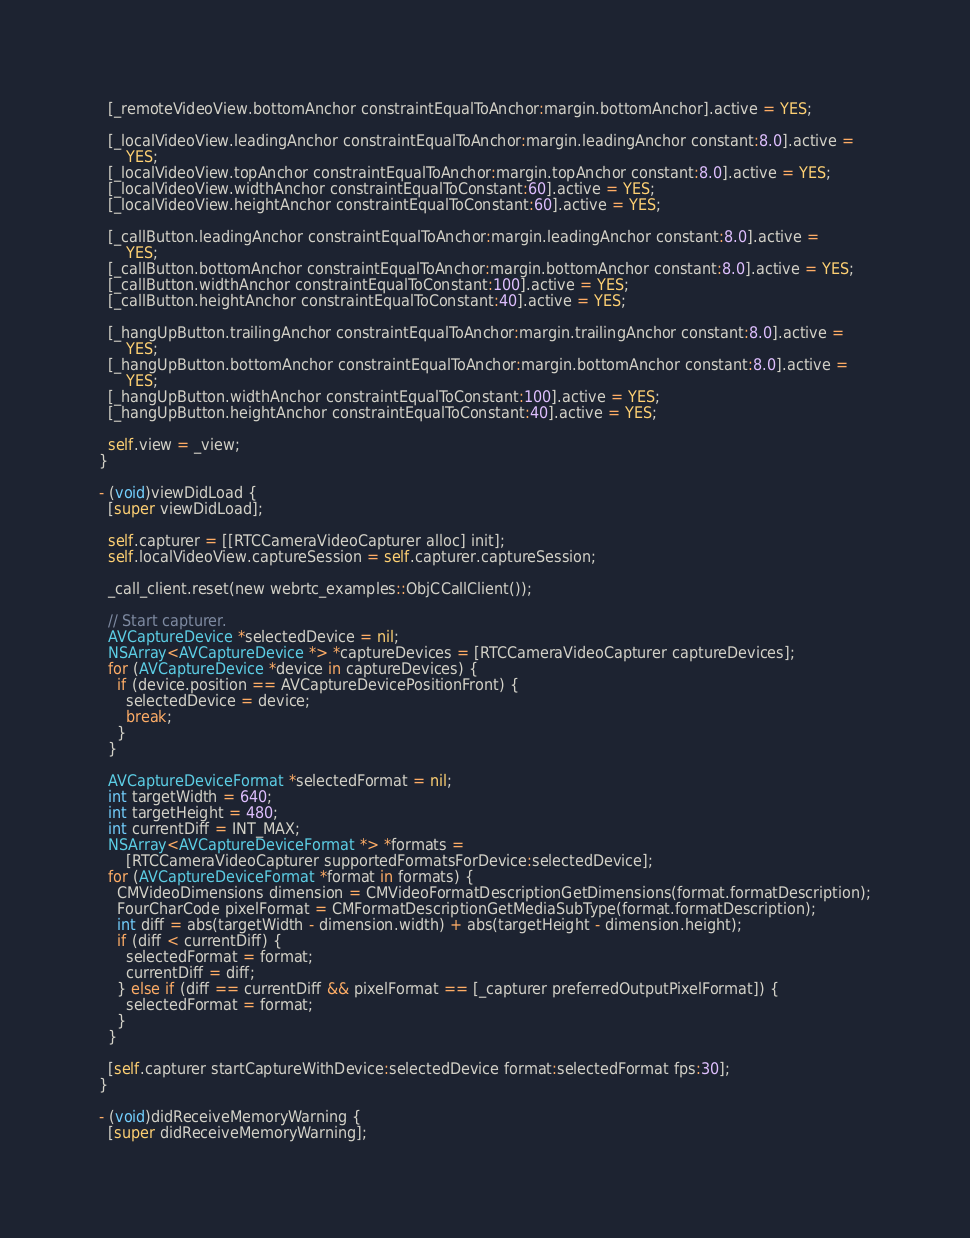<code> <loc_0><loc_0><loc_500><loc_500><_ObjectiveC_>  [_remoteVideoView.bottomAnchor constraintEqualToAnchor:margin.bottomAnchor].active = YES;

  [_localVideoView.leadingAnchor constraintEqualToAnchor:margin.leadingAnchor constant:8.0].active =
      YES;
  [_localVideoView.topAnchor constraintEqualToAnchor:margin.topAnchor constant:8.0].active = YES;
  [_localVideoView.widthAnchor constraintEqualToConstant:60].active = YES;
  [_localVideoView.heightAnchor constraintEqualToConstant:60].active = YES;

  [_callButton.leadingAnchor constraintEqualToAnchor:margin.leadingAnchor constant:8.0].active =
      YES;
  [_callButton.bottomAnchor constraintEqualToAnchor:margin.bottomAnchor constant:8.0].active = YES;
  [_callButton.widthAnchor constraintEqualToConstant:100].active = YES;
  [_callButton.heightAnchor constraintEqualToConstant:40].active = YES;

  [_hangUpButton.trailingAnchor constraintEqualToAnchor:margin.trailingAnchor constant:8.0].active =
      YES;
  [_hangUpButton.bottomAnchor constraintEqualToAnchor:margin.bottomAnchor constant:8.0].active =
      YES;
  [_hangUpButton.widthAnchor constraintEqualToConstant:100].active = YES;
  [_hangUpButton.heightAnchor constraintEqualToConstant:40].active = YES;

  self.view = _view;
}

- (void)viewDidLoad {
  [super viewDidLoad];

  self.capturer = [[RTCCameraVideoCapturer alloc] init];
  self.localVideoView.captureSession = self.capturer.captureSession;

  _call_client.reset(new webrtc_examples::ObjCCallClient());

  // Start capturer.
  AVCaptureDevice *selectedDevice = nil;
  NSArray<AVCaptureDevice *> *captureDevices = [RTCCameraVideoCapturer captureDevices];
  for (AVCaptureDevice *device in captureDevices) {
    if (device.position == AVCaptureDevicePositionFront) {
      selectedDevice = device;
      break;
    }
  }

  AVCaptureDeviceFormat *selectedFormat = nil;
  int targetWidth = 640;
  int targetHeight = 480;
  int currentDiff = INT_MAX;
  NSArray<AVCaptureDeviceFormat *> *formats =
      [RTCCameraVideoCapturer supportedFormatsForDevice:selectedDevice];
  for (AVCaptureDeviceFormat *format in formats) {
    CMVideoDimensions dimension = CMVideoFormatDescriptionGetDimensions(format.formatDescription);
    FourCharCode pixelFormat = CMFormatDescriptionGetMediaSubType(format.formatDescription);
    int diff = abs(targetWidth - dimension.width) + abs(targetHeight - dimension.height);
    if (diff < currentDiff) {
      selectedFormat = format;
      currentDiff = diff;
    } else if (diff == currentDiff && pixelFormat == [_capturer preferredOutputPixelFormat]) {
      selectedFormat = format;
    }
  }

  [self.capturer startCaptureWithDevice:selectedDevice format:selectedFormat fps:30];
}

- (void)didReceiveMemoryWarning {
  [super didReceiveMemoryWarning];</code> 